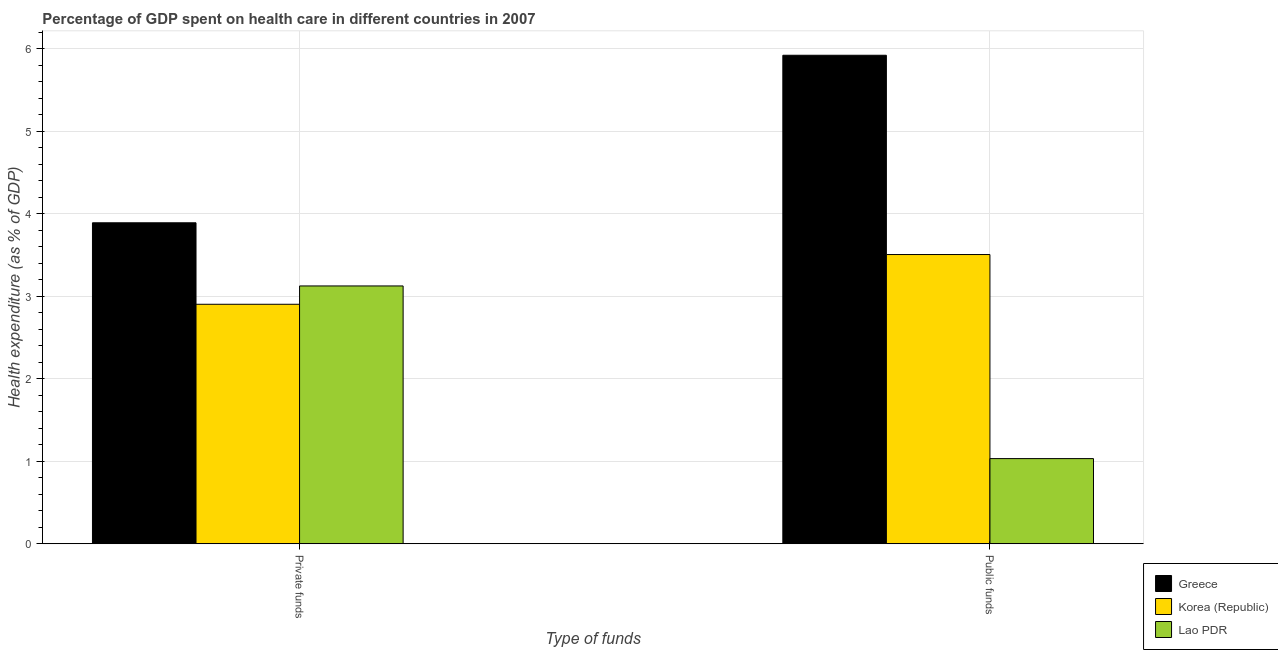How many different coloured bars are there?
Make the answer very short. 3. How many groups of bars are there?
Make the answer very short. 2. Are the number of bars on each tick of the X-axis equal?
Offer a very short reply. Yes. What is the label of the 1st group of bars from the left?
Provide a succinct answer. Private funds. What is the amount of public funds spent in healthcare in Greece?
Your response must be concise. 5.92. Across all countries, what is the maximum amount of private funds spent in healthcare?
Your answer should be compact. 3.89. Across all countries, what is the minimum amount of private funds spent in healthcare?
Your response must be concise. 2.9. What is the total amount of public funds spent in healthcare in the graph?
Your response must be concise. 10.46. What is the difference between the amount of public funds spent in healthcare in Lao PDR and that in Greece?
Offer a very short reply. -4.89. What is the difference between the amount of private funds spent in healthcare in Greece and the amount of public funds spent in healthcare in Korea (Republic)?
Provide a succinct answer. 0.38. What is the average amount of private funds spent in healthcare per country?
Offer a very short reply. 3.31. What is the difference between the amount of private funds spent in healthcare and amount of public funds spent in healthcare in Greece?
Your answer should be compact. -2.03. In how many countries, is the amount of public funds spent in healthcare greater than 4 %?
Ensure brevity in your answer.  1. What is the ratio of the amount of public funds spent in healthcare in Greece to that in Lao PDR?
Your response must be concise. 5.73. Is the amount of public funds spent in healthcare in Lao PDR less than that in Korea (Republic)?
Ensure brevity in your answer.  Yes. In how many countries, is the amount of private funds spent in healthcare greater than the average amount of private funds spent in healthcare taken over all countries?
Keep it short and to the point. 1. What does the 2nd bar from the left in Private funds represents?
Provide a succinct answer. Korea (Republic). What does the 1st bar from the right in Public funds represents?
Make the answer very short. Lao PDR. Does the graph contain grids?
Make the answer very short. Yes. Where does the legend appear in the graph?
Offer a very short reply. Bottom right. How many legend labels are there?
Give a very brief answer. 3. What is the title of the graph?
Your answer should be compact. Percentage of GDP spent on health care in different countries in 2007. Does "Uzbekistan" appear as one of the legend labels in the graph?
Give a very brief answer. No. What is the label or title of the X-axis?
Your answer should be very brief. Type of funds. What is the label or title of the Y-axis?
Offer a very short reply. Health expenditure (as % of GDP). What is the Health expenditure (as % of GDP) of Greece in Private funds?
Provide a short and direct response. 3.89. What is the Health expenditure (as % of GDP) in Korea (Republic) in Private funds?
Your response must be concise. 2.9. What is the Health expenditure (as % of GDP) in Lao PDR in Private funds?
Provide a short and direct response. 3.12. What is the Health expenditure (as % of GDP) in Greece in Public funds?
Your response must be concise. 5.92. What is the Health expenditure (as % of GDP) of Korea (Republic) in Public funds?
Your answer should be compact. 3.51. What is the Health expenditure (as % of GDP) of Lao PDR in Public funds?
Provide a succinct answer. 1.03. Across all Type of funds, what is the maximum Health expenditure (as % of GDP) of Greece?
Your answer should be compact. 5.92. Across all Type of funds, what is the maximum Health expenditure (as % of GDP) in Korea (Republic)?
Give a very brief answer. 3.51. Across all Type of funds, what is the maximum Health expenditure (as % of GDP) in Lao PDR?
Keep it short and to the point. 3.12. Across all Type of funds, what is the minimum Health expenditure (as % of GDP) of Greece?
Ensure brevity in your answer.  3.89. Across all Type of funds, what is the minimum Health expenditure (as % of GDP) in Korea (Republic)?
Your response must be concise. 2.9. Across all Type of funds, what is the minimum Health expenditure (as % of GDP) of Lao PDR?
Provide a short and direct response. 1.03. What is the total Health expenditure (as % of GDP) of Greece in the graph?
Your answer should be compact. 9.81. What is the total Health expenditure (as % of GDP) of Korea (Republic) in the graph?
Your response must be concise. 6.41. What is the total Health expenditure (as % of GDP) of Lao PDR in the graph?
Give a very brief answer. 4.16. What is the difference between the Health expenditure (as % of GDP) in Greece in Private funds and that in Public funds?
Offer a very short reply. -2.03. What is the difference between the Health expenditure (as % of GDP) in Korea (Republic) in Private funds and that in Public funds?
Offer a terse response. -0.6. What is the difference between the Health expenditure (as % of GDP) of Lao PDR in Private funds and that in Public funds?
Make the answer very short. 2.09. What is the difference between the Health expenditure (as % of GDP) in Greece in Private funds and the Health expenditure (as % of GDP) in Korea (Republic) in Public funds?
Your answer should be compact. 0.38. What is the difference between the Health expenditure (as % of GDP) in Greece in Private funds and the Health expenditure (as % of GDP) in Lao PDR in Public funds?
Ensure brevity in your answer.  2.86. What is the difference between the Health expenditure (as % of GDP) of Korea (Republic) in Private funds and the Health expenditure (as % of GDP) of Lao PDR in Public funds?
Provide a succinct answer. 1.87. What is the average Health expenditure (as % of GDP) in Greece per Type of funds?
Your answer should be very brief. 4.91. What is the average Health expenditure (as % of GDP) in Korea (Republic) per Type of funds?
Your answer should be very brief. 3.2. What is the average Health expenditure (as % of GDP) of Lao PDR per Type of funds?
Provide a succinct answer. 2.08. What is the difference between the Health expenditure (as % of GDP) of Greece and Health expenditure (as % of GDP) of Korea (Republic) in Private funds?
Provide a short and direct response. 0.99. What is the difference between the Health expenditure (as % of GDP) of Greece and Health expenditure (as % of GDP) of Lao PDR in Private funds?
Give a very brief answer. 0.77. What is the difference between the Health expenditure (as % of GDP) in Korea (Republic) and Health expenditure (as % of GDP) in Lao PDR in Private funds?
Provide a succinct answer. -0.22. What is the difference between the Health expenditure (as % of GDP) of Greece and Health expenditure (as % of GDP) of Korea (Republic) in Public funds?
Your answer should be very brief. 2.42. What is the difference between the Health expenditure (as % of GDP) in Greece and Health expenditure (as % of GDP) in Lao PDR in Public funds?
Provide a succinct answer. 4.89. What is the difference between the Health expenditure (as % of GDP) of Korea (Republic) and Health expenditure (as % of GDP) of Lao PDR in Public funds?
Provide a succinct answer. 2.47. What is the ratio of the Health expenditure (as % of GDP) of Greece in Private funds to that in Public funds?
Your answer should be very brief. 0.66. What is the ratio of the Health expenditure (as % of GDP) in Korea (Republic) in Private funds to that in Public funds?
Keep it short and to the point. 0.83. What is the ratio of the Health expenditure (as % of GDP) of Lao PDR in Private funds to that in Public funds?
Keep it short and to the point. 3.03. What is the difference between the highest and the second highest Health expenditure (as % of GDP) in Greece?
Offer a terse response. 2.03. What is the difference between the highest and the second highest Health expenditure (as % of GDP) of Korea (Republic)?
Your answer should be very brief. 0.6. What is the difference between the highest and the second highest Health expenditure (as % of GDP) in Lao PDR?
Keep it short and to the point. 2.09. What is the difference between the highest and the lowest Health expenditure (as % of GDP) in Greece?
Keep it short and to the point. 2.03. What is the difference between the highest and the lowest Health expenditure (as % of GDP) in Korea (Republic)?
Your response must be concise. 0.6. What is the difference between the highest and the lowest Health expenditure (as % of GDP) of Lao PDR?
Provide a succinct answer. 2.09. 